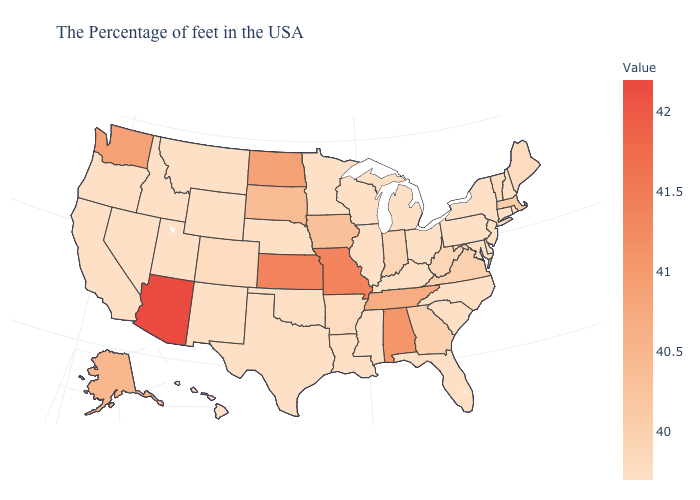Is the legend a continuous bar?
Short answer required. Yes. Does Oregon have the lowest value in the USA?
Give a very brief answer. Yes. Which states hav the highest value in the MidWest?
Give a very brief answer. Missouri, Kansas. Among the states that border Arizona , does Colorado have the highest value?
Short answer required. Yes. Which states have the lowest value in the USA?
Keep it brief. Rhode Island, New Hampshire, Connecticut, New York, New Jersey, Delaware, Maryland, Pennsylvania, North Carolina, South Carolina, Ohio, Florida, Michigan, Kentucky, Wisconsin, Illinois, Mississippi, Louisiana, Minnesota, Nebraska, Oklahoma, Texas, Wyoming, New Mexico, Utah, Montana, Idaho, Nevada, California, Oregon, Hawaii. Which states have the lowest value in the MidWest?
Be succinct. Ohio, Michigan, Wisconsin, Illinois, Minnesota, Nebraska. 